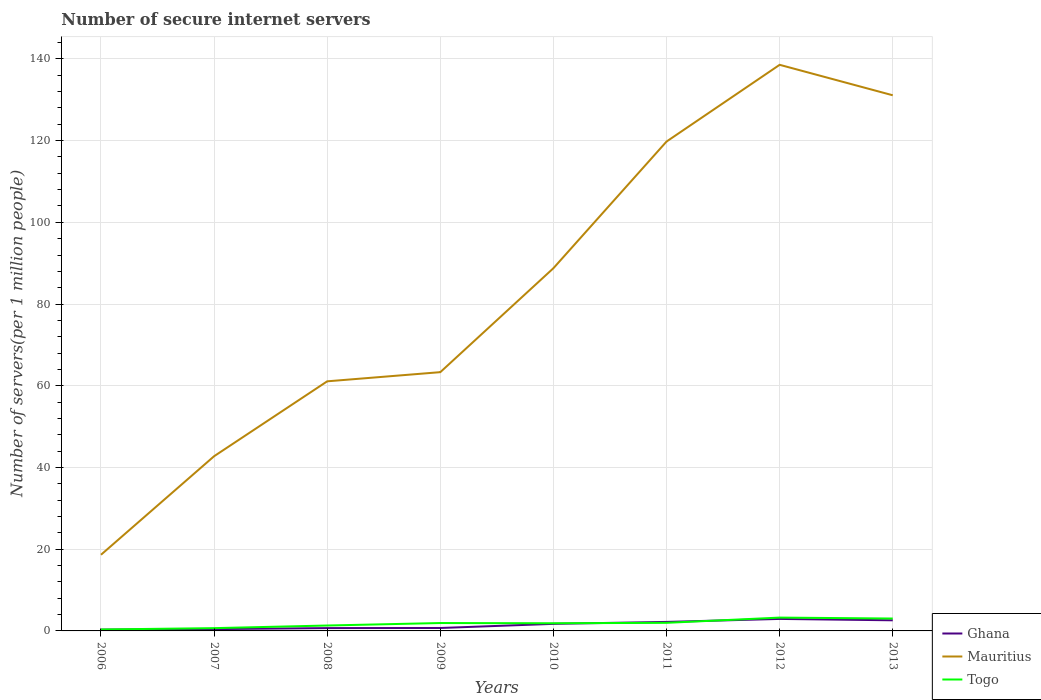Does the line corresponding to Togo intersect with the line corresponding to Mauritius?
Your answer should be very brief. No. Is the number of lines equal to the number of legend labels?
Offer a very short reply. Yes. Across all years, what is the maximum number of secure internet servers in Togo?
Make the answer very short. 0.35. In which year was the number of secure internet servers in Mauritius maximum?
Make the answer very short. 2006. What is the total number of secure internet servers in Mauritius in the graph?
Ensure brevity in your answer.  7.46. What is the difference between the highest and the second highest number of secure internet servers in Ghana?
Your answer should be compact. 2.62. What is the difference between the highest and the lowest number of secure internet servers in Ghana?
Make the answer very short. 4. How many years are there in the graph?
Provide a succinct answer. 8. Are the values on the major ticks of Y-axis written in scientific E-notation?
Ensure brevity in your answer.  No. Does the graph contain grids?
Offer a very short reply. Yes. Where does the legend appear in the graph?
Ensure brevity in your answer.  Bottom right. How many legend labels are there?
Offer a terse response. 3. What is the title of the graph?
Provide a short and direct response. Number of secure internet servers. What is the label or title of the X-axis?
Provide a succinct answer. Years. What is the label or title of the Y-axis?
Offer a very short reply. Number of servers(per 1 million people). What is the Number of servers(per 1 million people) in Ghana in 2006?
Keep it short and to the point. 0.32. What is the Number of servers(per 1 million people) of Mauritius in 2006?
Offer a very short reply. 18.64. What is the Number of servers(per 1 million people) in Togo in 2006?
Keep it short and to the point. 0.35. What is the Number of servers(per 1 million people) of Ghana in 2007?
Offer a very short reply. 0.44. What is the Number of servers(per 1 million people) in Mauritius in 2007?
Provide a succinct answer. 42.75. What is the Number of servers(per 1 million people) of Togo in 2007?
Your answer should be very brief. 0.68. What is the Number of servers(per 1 million people) in Ghana in 2008?
Provide a succinct answer. 0.69. What is the Number of servers(per 1 million people) in Mauritius in 2008?
Provide a short and direct response. 61.09. What is the Number of servers(per 1 million people) in Togo in 2008?
Ensure brevity in your answer.  1.32. What is the Number of servers(per 1 million people) in Ghana in 2009?
Ensure brevity in your answer.  0.72. What is the Number of servers(per 1 million people) of Mauritius in 2009?
Your answer should be very brief. 63.33. What is the Number of servers(per 1 million people) in Togo in 2009?
Your response must be concise. 1.93. What is the Number of servers(per 1 million people) of Ghana in 2010?
Offer a terse response. 1.73. What is the Number of servers(per 1 million people) in Mauritius in 2010?
Keep it short and to the point. 88.77. What is the Number of servers(per 1 million people) in Togo in 2010?
Keep it short and to the point. 1.88. What is the Number of servers(per 1 million people) in Ghana in 2011?
Give a very brief answer. 2.21. What is the Number of servers(per 1 million people) of Mauritius in 2011?
Offer a terse response. 119.77. What is the Number of servers(per 1 million people) in Togo in 2011?
Offer a terse response. 1.98. What is the Number of servers(per 1 million people) of Ghana in 2012?
Ensure brevity in your answer.  2.94. What is the Number of servers(per 1 million people) in Mauritius in 2012?
Give a very brief answer. 138.55. What is the Number of servers(per 1 million people) in Togo in 2012?
Offer a very short reply. 3.26. What is the Number of servers(per 1 million people) in Ghana in 2013?
Keep it short and to the point. 2.6. What is the Number of servers(per 1 million people) in Mauritius in 2013?
Your answer should be compact. 131.09. What is the Number of servers(per 1 million people) in Togo in 2013?
Your answer should be compact. 3.03. Across all years, what is the maximum Number of servers(per 1 million people) in Ghana?
Your response must be concise. 2.94. Across all years, what is the maximum Number of servers(per 1 million people) of Mauritius?
Offer a very short reply. 138.55. Across all years, what is the maximum Number of servers(per 1 million people) in Togo?
Give a very brief answer. 3.26. Across all years, what is the minimum Number of servers(per 1 million people) in Ghana?
Your response must be concise. 0.32. Across all years, what is the minimum Number of servers(per 1 million people) of Mauritius?
Offer a very short reply. 18.64. Across all years, what is the minimum Number of servers(per 1 million people) of Togo?
Offer a very short reply. 0.35. What is the total Number of servers(per 1 million people) in Ghana in the graph?
Give a very brief answer. 11.64. What is the total Number of servers(per 1 million people) in Mauritius in the graph?
Your answer should be very brief. 663.99. What is the total Number of servers(per 1 million people) of Togo in the graph?
Give a very brief answer. 14.43. What is the difference between the Number of servers(per 1 million people) in Ghana in 2006 and that in 2007?
Make the answer very short. -0.12. What is the difference between the Number of servers(per 1 million people) of Mauritius in 2006 and that in 2007?
Your answer should be very brief. -24.12. What is the difference between the Number of servers(per 1 million people) in Togo in 2006 and that in 2007?
Provide a short and direct response. -0.33. What is the difference between the Number of servers(per 1 million people) in Ghana in 2006 and that in 2008?
Provide a short and direct response. -0.37. What is the difference between the Number of servers(per 1 million people) of Mauritius in 2006 and that in 2008?
Offer a terse response. -42.45. What is the difference between the Number of servers(per 1 million people) of Togo in 2006 and that in 2008?
Make the answer very short. -0.97. What is the difference between the Number of servers(per 1 million people) in Ghana in 2006 and that in 2009?
Your answer should be very brief. -0.4. What is the difference between the Number of servers(per 1 million people) in Mauritius in 2006 and that in 2009?
Make the answer very short. -44.69. What is the difference between the Number of servers(per 1 million people) in Togo in 2006 and that in 2009?
Provide a succinct answer. -1.58. What is the difference between the Number of servers(per 1 million people) in Ghana in 2006 and that in 2010?
Give a very brief answer. -1.41. What is the difference between the Number of servers(per 1 million people) of Mauritius in 2006 and that in 2010?
Give a very brief answer. -70.13. What is the difference between the Number of servers(per 1 million people) in Togo in 2006 and that in 2010?
Your response must be concise. -1.53. What is the difference between the Number of servers(per 1 million people) in Ghana in 2006 and that in 2011?
Ensure brevity in your answer.  -1.89. What is the difference between the Number of servers(per 1 million people) in Mauritius in 2006 and that in 2011?
Keep it short and to the point. -101.13. What is the difference between the Number of servers(per 1 million people) in Togo in 2006 and that in 2011?
Offer a very short reply. -1.63. What is the difference between the Number of servers(per 1 million people) in Ghana in 2006 and that in 2012?
Make the answer very short. -2.62. What is the difference between the Number of servers(per 1 million people) in Mauritius in 2006 and that in 2012?
Keep it short and to the point. -119.91. What is the difference between the Number of servers(per 1 million people) in Togo in 2006 and that in 2012?
Keep it short and to the point. -2.91. What is the difference between the Number of servers(per 1 million people) of Ghana in 2006 and that in 2013?
Your response must be concise. -2.28. What is the difference between the Number of servers(per 1 million people) in Mauritius in 2006 and that in 2013?
Ensure brevity in your answer.  -112.45. What is the difference between the Number of servers(per 1 million people) of Togo in 2006 and that in 2013?
Provide a short and direct response. -2.68. What is the difference between the Number of servers(per 1 million people) of Ghana in 2007 and that in 2008?
Keep it short and to the point. -0.25. What is the difference between the Number of servers(per 1 million people) of Mauritius in 2007 and that in 2008?
Ensure brevity in your answer.  -18.33. What is the difference between the Number of servers(per 1 million people) of Togo in 2007 and that in 2008?
Your response must be concise. -0.64. What is the difference between the Number of servers(per 1 million people) of Ghana in 2007 and that in 2009?
Make the answer very short. -0.27. What is the difference between the Number of servers(per 1 million people) in Mauritius in 2007 and that in 2009?
Make the answer very short. -20.58. What is the difference between the Number of servers(per 1 million people) of Togo in 2007 and that in 2009?
Ensure brevity in your answer.  -1.25. What is the difference between the Number of servers(per 1 million people) in Ghana in 2007 and that in 2010?
Your response must be concise. -1.28. What is the difference between the Number of servers(per 1 million people) in Mauritius in 2007 and that in 2010?
Make the answer very short. -46.02. What is the difference between the Number of servers(per 1 million people) in Togo in 2007 and that in 2010?
Provide a succinct answer. -1.2. What is the difference between the Number of servers(per 1 million people) of Ghana in 2007 and that in 2011?
Your answer should be compact. -1.76. What is the difference between the Number of servers(per 1 million people) in Mauritius in 2007 and that in 2011?
Your answer should be very brief. -77.02. What is the difference between the Number of servers(per 1 million people) of Togo in 2007 and that in 2011?
Provide a succinct answer. -1.3. What is the difference between the Number of servers(per 1 million people) in Ghana in 2007 and that in 2012?
Give a very brief answer. -2.49. What is the difference between the Number of servers(per 1 million people) in Mauritius in 2007 and that in 2012?
Provide a short and direct response. -95.79. What is the difference between the Number of servers(per 1 million people) of Togo in 2007 and that in 2012?
Offer a very short reply. -2.58. What is the difference between the Number of servers(per 1 million people) in Ghana in 2007 and that in 2013?
Your response must be concise. -2.16. What is the difference between the Number of servers(per 1 million people) of Mauritius in 2007 and that in 2013?
Give a very brief answer. -88.34. What is the difference between the Number of servers(per 1 million people) in Togo in 2007 and that in 2013?
Give a very brief answer. -2.35. What is the difference between the Number of servers(per 1 million people) of Ghana in 2008 and that in 2009?
Keep it short and to the point. -0.02. What is the difference between the Number of servers(per 1 million people) in Mauritius in 2008 and that in 2009?
Provide a short and direct response. -2.24. What is the difference between the Number of servers(per 1 million people) in Togo in 2008 and that in 2009?
Your response must be concise. -0.61. What is the difference between the Number of servers(per 1 million people) in Ghana in 2008 and that in 2010?
Provide a short and direct response. -1.03. What is the difference between the Number of servers(per 1 million people) of Mauritius in 2008 and that in 2010?
Your answer should be compact. -27.68. What is the difference between the Number of servers(per 1 million people) in Togo in 2008 and that in 2010?
Offer a very short reply. -0.56. What is the difference between the Number of servers(per 1 million people) of Ghana in 2008 and that in 2011?
Offer a terse response. -1.51. What is the difference between the Number of servers(per 1 million people) in Mauritius in 2008 and that in 2011?
Your answer should be compact. -58.68. What is the difference between the Number of servers(per 1 million people) in Togo in 2008 and that in 2011?
Offer a very short reply. -0.66. What is the difference between the Number of servers(per 1 million people) of Ghana in 2008 and that in 2012?
Offer a terse response. -2.24. What is the difference between the Number of servers(per 1 million people) in Mauritius in 2008 and that in 2012?
Keep it short and to the point. -77.46. What is the difference between the Number of servers(per 1 million people) in Togo in 2008 and that in 2012?
Provide a short and direct response. -1.94. What is the difference between the Number of servers(per 1 million people) in Ghana in 2008 and that in 2013?
Make the answer very short. -1.91. What is the difference between the Number of servers(per 1 million people) of Mauritius in 2008 and that in 2013?
Make the answer very short. -70.01. What is the difference between the Number of servers(per 1 million people) in Togo in 2008 and that in 2013?
Provide a short and direct response. -1.71. What is the difference between the Number of servers(per 1 million people) of Ghana in 2009 and that in 2010?
Provide a succinct answer. -1.01. What is the difference between the Number of servers(per 1 million people) in Mauritius in 2009 and that in 2010?
Keep it short and to the point. -25.44. What is the difference between the Number of servers(per 1 million people) of Togo in 2009 and that in 2010?
Keep it short and to the point. 0.05. What is the difference between the Number of servers(per 1 million people) of Ghana in 2009 and that in 2011?
Give a very brief answer. -1.49. What is the difference between the Number of servers(per 1 million people) of Mauritius in 2009 and that in 2011?
Make the answer very short. -56.44. What is the difference between the Number of servers(per 1 million people) of Togo in 2009 and that in 2011?
Your response must be concise. -0.05. What is the difference between the Number of servers(per 1 million people) in Ghana in 2009 and that in 2012?
Ensure brevity in your answer.  -2.22. What is the difference between the Number of servers(per 1 million people) of Mauritius in 2009 and that in 2012?
Give a very brief answer. -75.22. What is the difference between the Number of servers(per 1 million people) in Togo in 2009 and that in 2012?
Ensure brevity in your answer.  -1.33. What is the difference between the Number of servers(per 1 million people) of Ghana in 2009 and that in 2013?
Give a very brief answer. -1.88. What is the difference between the Number of servers(per 1 million people) of Mauritius in 2009 and that in 2013?
Give a very brief answer. -67.76. What is the difference between the Number of servers(per 1 million people) in Togo in 2009 and that in 2013?
Make the answer very short. -1.1. What is the difference between the Number of servers(per 1 million people) in Ghana in 2010 and that in 2011?
Offer a terse response. -0.48. What is the difference between the Number of servers(per 1 million people) in Mauritius in 2010 and that in 2011?
Give a very brief answer. -31. What is the difference between the Number of servers(per 1 million people) in Togo in 2010 and that in 2011?
Offer a terse response. -0.1. What is the difference between the Number of servers(per 1 million people) of Ghana in 2010 and that in 2012?
Provide a succinct answer. -1.21. What is the difference between the Number of servers(per 1 million people) of Mauritius in 2010 and that in 2012?
Keep it short and to the point. -49.78. What is the difference between the Number of servers(per 1 million people) in Togo in 2010 and that in 2012?
Keep it short and to the point. -1.38. What is the difference between the Number of servers(per 1 million people) in Ghana in 2010 and that in 2013?
Provide a succinct answer. -0.87. What is the difference between the Number of servers(per 1 million people) in Mauritius in 2010 and that in 2013?
Offer a terse response. -42.32. What is the difference between the Number of servers(per 1 million people) of Togo in 2010 and that in 2013?
Make the answer very short. -1.15. What is the difference between the Number of servers(per 1 million people) of Ghana in 2011 and that in 2012?
Give a very brief answer. -0.73. What is the difference between the Number of servers(per 1 million people) in Mauritius in 2011 and that in 2012?
Your response must be concise. -18.78. What is the difference between the Number of servers(per 1 million people) in Togo in 2011 and that in 2012?
Provide a short and direct response. -1.28. What is the difference between the Number of servers(per 1 million people) in Ghana in 2011 and that in 2013?
Offer a terse response. -0.39. What is the difference between the Number of servers(per 1 million people) in Mauritius in 2011 and that in 2013?
Keep it short and to the point. -11.32. What is the difference between the Number of servers(per 1 million people) of Togo in 2011 and that in 2013?
Your response must be concise. -1.05. What is the difference between the Number of servers(per 1 million people) of Ghana in 2012 and that in 2013?
Make the answer very short. 0.34. What is the difference between the Number of servers(per 1 million people) in Mauritius in 2012 and that in 2013?
Your answer should be very brief. 7.46. What is the difference between the Number of servers(per 1 million people) in Togo in 2012 and that in 2013?
Keep it short and to the point. 0.23. What is the difference between the Number of servers(per 1 million people) in Ghana in 2006 and the Number of servers(per 1 million people) in Mauritius in 2007?
Offer a very short reply. -42.44. What is the difference between the Number of servers(per 1 million people) of Ghana in 2006 and the Number of servers(per 1 million people) of Togo in 2007?
Keep it short and to the point. -0.36. What is the difference between the Number of servers(per 1 million people) in Mauritius in 2006 and the Number of servers(per 1 million people) in Togo in 2007?
Offer a terse response. 17.96. What is the difference between the Number of servers(per 1 million people) in Ghana in 2006 and the Number of servers(per 1 million people) in Mauritius in 2008?
Your answer should be very brief. -60.77. What is the difference between the Number of servers(per 1 million people) in Ghana in 2006 and the Number of servers(per 1 million people) in Togo in 2008?
Give a very brief answer. -1. What is the difference between the Number of servers(per 1 million people) of Mauritius in 2006 and the Number of servers(per 1 million people) of Togo in 2008?
Provide a short and direct response. 17.32. What is the difference between the Number of servers(per 1 million people) in Ghana in 2006 and the Number of servers(per 1 million people) in Mauritius in 2009?
Offer a terse response. -63.01. What is the difference between the Number of servers(per 1 million people) in Ghana in 2006 and the Number of servers(per 1 million people) in Togo in 2009?
Offer a terse response. -1.61. What is the difference between the Number of servers(per 1 million people) of Mauritius in 2006 and the Number of servers(per 1 million people) of Togo in 2009?
Offer a terse response. 16.71. What is the difference between the Number of servers(per 1 million people) in Ghana in 2006 and the Number of servers(per 1 million people) in Mauritius in 2010?
Provide a succinct answer. -88.45. What is the difference between the Number of servers(per 1 million people) of Ghana in 2006 and the Number of servers(per 1 million people) of Togo in 2010?
Ensure brevity in your answer.  -1.56. What is the difference between the Number of servers(per 1 million people) in Mauritius in 2006 and the Number of servers(per 1 million people) in Togo in 2010?
Your answer should be compact. 16.76. What is the difference between the Number of servers(per 1 million people) of Ghana in 2006 and the Number of servers(per 1 million people) of Mauritius in 2011?
Your answer should be compact. -119.45. What is the difference between the Number of servers(per 1 million people) of Ghana in 2006 and the Number of servers(per 1 million people) of Togo in 2011?
Offer a terse response. -1.66. What is the difference between the Number of servers(per 1 million people) of Mauritius in 2006 and the Number of servers(per 1 million people) of Togo in 2011?
Your answer should be very brief. 16.66. What is the difference between the Number of servers(per 1 million people) in Ghana in 2006 and the Number of servers(per 1 million people) in Mauritius in 2012?
Provide a succinct answer. -138.23. What is the difference between the Number of servers(per 1 million people) of Ghana in 2006 and the Number of servers(per 1 million people) of Togo in 2012?
Provide a short and direct response. -2.94. What is the difference between the Number of servers(per 1 million people) of Mauritius in 2006 and the Number of servers(per 1 million people) of Togo in 2012?
Provide a succinct answer. 15.38. What is the difference between the Number of servers(per 1 million people) in Ghana in 2006 and the Number of servers(per 1 million people) in Mauritius in 2013?
Your response must be concise. -130.77. What is the difference between the Number of servers(per 1 million people) in Ghana in 2006 and the Number of servers(per 1 million people) in Togo in 2013?
Your response must be concise. -2.71. What is the difference between the Number of servers(per 1 million people) of Mauritius in 2006 and the Number of servers(per 1 million people) of Togo in 2013?
Offer a very short reply. 15.61. What is the difference between the Number of servers(per 1 million people) of Ghana in 2007 and the Number of servers(per 1 million people) of Mauritius in 2008?
Offer a very short reply. -60.64. What is the difference between the Number of servers(per 1 million people) in Ghana in 2007 and the Number of servers(per 1 million people) in Togo in 2008?
Keep it short and to the point. -0.88. What is the difference between the Number of servers(per 1 million people) in Mauritius in 2007 and the Number of servers(per 1 million people) in Togo in 2008?
Provide a succinct answer. 41.43. What is the difference between the Number of servers(per 1 million people) in Ghana in 2007 and the Number of servers(per 1 million people) in Mauritius in 2009?
Make the answer very short. -62.89. What is the difference between the Number of servers(per 1 million people) of Ghana in 2007 and the Number of servers(per 1 million people) of Togo in 2009?
Provide a short and direct response. -1.49. What is the difference between the Number of servers(per 1 million people) in Mauritius in 2007 and the Number of servers(per 1 million people) in Togo in 2009?
Offer a very short reply. 40.83. What is the difference between the Number of servers(per 1 million people) of Ghana in 2007 and the Number of servers(per 1 million people) of Mauritius in 2010?
Your answer should be very brief. -88.33. What is the difference between the Number of servers(per 1 million people) of Ghana in 2007 and the Number of servers(per 1 million people) of Togo in 2010?
Ensure brevity in your answer.  -1.43. What is the difference between the Number of servers(per 1 million people) in Mauritius in 2007 and the Number of servers(per 1 million people) in Togo in 2010?
Your answer should be compact. 40.88. What is the difference between the Number of servers(per 1 million people) in Ghana in 2007 and the Number of servers(per 1 million people) in Mauritius in 2011?
Your response must be concise. -119.33. What is the difference between the Number of servers(per 1 million people) of Ghana in 2007 and the Number of servers(per 1 million people) of Togo in 2011?
Offer a very short reply. -1.54. What is the difference between the Number of servers(per 1 million people) of Mauritius in 2007 and the Number of servers(per 1 million people) of Togo in 2011?
Keep it short and to the point. 40.77. What is the difference between the Number of servers(per 1 million people) of Ghana in 2007 and the Number of servers(per 1 million people) of Mauritius in 2012?
Provide a short and direct response. -138.1. What is the difference between the Number of servers(per 1 million people) of Ghana in 2007 and the Number of servers(per 1 million people) of Togo in 2012?
Provide a succinct answer. -2.82. What is the difference between the Number of servers(per 1 million people) in Mauritius in 2007 and the Number of servers(per 1 million people) in Togo in 2012?
Offer a terse response. 39.49. What is the difference between the Number of servers(per 1 million people) of Ghana in 2007 and the Number of servers(per 1 million people) of Mauritius in 2013?
Make the answer very short. -130.65. What is the difference between the Number of servers(per 1 million people) in Ghana in 2007 and the Number of servers(per 1 million people) in Togo in 2013?
Give a very brief answer. -2.59. What is the difference between the Number of servers(per 1 million people) in Mauritius in 2007 and the Number of servers(per 1 million people) in Togo in 2013?
Keep it short and to the point. 39.72. What is the difference between the Number of servers(per 1 million people) in Ghana in 2008 and the Number of servers(per 1 million people) in Mauritius in 2009?
Keep it short and to the point. -62.64. What is the difference between the Number of servers(per 1 million people) in Ghana in 2008 and the Number of servers(per 1 million people) in Togo in 2009?
Make the answer very short. -1.24. What is the difference between the Number of servers(per 1 million people) in Mauritius in 2008 and the Number of servers(per 1 million people) in Togo in 2009?
Ensure brevity in your answer.  59.16. What is the difference between the Number of servers(per 1 million people) of Ghana in 2008 and the Number of servers(per 1 million people) of Mauritius in 2010?
Offer a very short reply. -88.08. What is the difference between the Number of servers(per 1 million people) of Ghana in 2008 and the Number of servers(per 1 million people) of Togo in 2010?
Make the answer very short. -1.19. What is the difference between the Number of servers(per 1 million people) of Mauritius in 2008 and the Number of servers(per 1 million people) of Togo in 2010?
Provide a short and direct response. 59.21. What is the difference between the Number of servers(per 1 million people) in Ghana in 2008 and the Number of servers(per 1 million people) in Mauritius in 2011?
Keep it short and to the point. -119.08. What is the difference between the Number of servers(per 1 million people) of Ghana in 2008 and the Number of servers(per 1 million people) of Togo in 2011?
Provide a succinct answer. -1.29. What is the difference between the Number of servers(per 1 million people) of Mauritius in 2008 and the Number of servers(per 1 million people) of Togo in 2011?
Provide a short and direct response. 59.11. What is the difference between the Number of servers(per 1 million people) in Ghana in 2008 and the Number of servers(per 1 million people) in Mauritius in 2012?
Offer a very short reply. -137.86. What is the difference between the Number of servers(per 1 million people) of Ghana in 2008 and the Number of servers(per 1 million people) of Togo in 2012?
Keep it short and to the point. -2.57. What is the difference between the Number of servers(per 1 million people) of Mauritius in 2008 and the Number of servers(per 1 million people) of Togo in 2012?
Offer a terse response. 57.83. What is the difference between the Number of servers(per 1 million people) in Ghana in 2008 and the Number of servers(per 1 million people) in Mauritius in 2013?
Make the answer very short. -130.4. What is the difference between the Number of servers(per 1 million people) in Ghana in 2008 and the Number of servers(per 1 million people) in Togo in 2013?
Provide a succinct answer. -2.34. What is the difference between the Number of servers(per 1 million people) in Mauritius in 2008 and the Number of servers(per 1 million people) in Togo in 2013?
Your response must be concise. 58.06. What is the difference between the Number of servers(per 1 million people) in Ghana in 2009 and the Number of servers(per 1 million people) in Mauritius in 2010?
Offer a very short reply. -88.05. What is the difference between the Number of servers(per 1 million people) in Ghana in 2009 and the Number of servers(per 1 million people) in Togo in 2010?
Your response must be concise. -1.16. What is the difference between the Number of servers(per 1 million people) of Mauritius in 2009 and the Number of servers(per 1 million people) of Togo in 2010?
Offer a terse response. 61.45. What is the difference between the Number of servers(per 1 million people) of Ghana in 2009 and the Number of servers(per 1 million people) of Mauritius in 2011?
Offer a very short reply. -119.05. What is the difference between the Number of servers(per 1 million people) in Ghana in 2009 and the Number of servers(per 1 million people) in Togo in 2011?
Your response must be concise. -1.26. What is the difference between the Number of servers(per 1 million people) in Mauritius in 2009 and the Number of servers(per 1 million people) in Togo in 2011?
Your answer should be very brief. 61.35. What is the difference between the Number of servers(per 1 million people) in Ghana in 2009 and the Number of servers(per 1 million people) in Mauritius in 2012?
Make the answer very short. -137.83. What is the difference between the Number of servers(per 1 million people) in Ghana in 2009 and the Number of servers(per 1 million people) in Togo in 2012?
Keep it short and to the point. -2.54. What is the difference between the Number of servers(per 1 million people) in Mauritius in 2009 and the Number of servers(per 1 million people) in Togo in 2012?
Provide a short and direct response. 60.07. What is the difference between the Number of servers(per 1 million people) in Ghana in 2009 and the Number of servers(per 1 million people) in Mauritius in 2013?
Offer a terse response. -130.38. What is the difference between the Number of servers(per 1 million people) in Ghana in 2009 and the Number of servers(per 1 million people) in Togo in 2013?
Offer a terse response. -2.31. What is the difference between the Number of servers(per 1 million people) of Mauritius in 2009 and the Number of servers(per 1 million people) of Togo in 2013?
Your answer should be very brief. 60.3. What is the difference between the Number of servers(per 1 million people) of Ghana in 2010 and the Number of servers(per 1 million people) of Mauritius in 2011?
Give a very brief answer. -118.04. What is the difference between the Number of servers(per 1 million people) of Ghana in 2010 and the Number of servers(per 1 million people) of Togo in 2011?
Your response must be concise. -0.25. What is the difference between the Number of servers(per 1 million people) in Mauritius in 2010 and the Number of servers(per 1 million people) in Togo in 2011?
Offer a very short reply. 86.79. What is the difference between the Number of servers(per 1 million people) in Ghana in 2010 and the Number of servers(per 1 million people) in Mauritius in 2012?
Ensure brevity in your answer.  -136.82. What is the difference between the Number of servers(per 1 million people) of Ghana in 2010 and the Number of servers(per 1 million people) of Togo in 2012?
Offer a very short reply. -1.53. What is the difference between the Number of servers(per 1 million people) of Mauritius in 2010 and the Number of servers(per 1 million people) of Togo in 2012?
Ensure brevity in your answer.  85.51. What is the difference between the Number of servers(per 1 million people) in Ghana in 2010 and the Number of servers(per 1 million people) in Mauritius in 2013?
Provide a succinct answer. -129.37. What is the difference between the Number of servers(per 1 million people) in Ghana in 2010 and the Number of servers(per 1 million people) in Togo in 2013?
Your response must be concise. -1.3. What is the difference between the Number of servers(per 1 million people) in Mauritius in 2010 and the Number of servers(per 1 million people) in Togo in 2013?
Your answer should be compact. 85.74. What is the difference between the Number of servers(per 1 million people) in Ghana in 2011 and the Number of servers(per 1 million people) in Mauritius in 2012?
Give a very brief answer. -136.34. What is the difference between the Number of servers(per 1 million people) in Ghana in 2011 and the Number of servers(per 1 million people) in Togo in 2012?
Offer a terse response. -1.06. What is the difference between the Number of servers(per 1 million people) in Mauritius in 2011 and the Number of servers(per 1 million people) in Togo in 2012?
Offer a terse response. 116.51. What is the difference between the Number of servers(per 1 million people) in Ghana in 2011 and the Number of servers(per 1 million people) in Mauritius in 2013?
Offer a very short reply. -128.89. What is the difference between the Number of servers(per 1 million people) in Ghana in 2011 and the Number of servers(per 1 million people) in Togo in 2013?
Provide a short and direct response. -0.82. What is the difference between the Number of servers(per 1 million people) of Mauritius in 2011 and the Number of servers(per 1 million people) of Togo in 2013?
Make the answer very short. 116.74. What is the difference between the Number of servers(per 1 million people) of Ghana in 2012 and the Number of servers(per 1 million people) of Mauritius in 2013?
Offer a very short reply. -128.16. What is the difference between the Number of servers(per 1 million people) in Ghana in 2012 and the Number of servers(per 1 million people) in Togo in 2013?
Your answer should be compact. -0.09. What is the difference between the Number of servers(per 1 million people) of Mauritius in 2012 and the Number of servers(per 1 million people) of Togo in 2013?
Your response must be concise. 135.52. What is the average Number of servers(per 1 million people) of Ghana per year?
Provide a short and direct response. 1.46. What is the average Number of servers(per 1 million people) in Mauritius per year?
Give a very brief answer. 83. What is the average Number of servers(per 1 million people) in Togo per year?
Give a very brief answer. 1.8. In the year 2006, what is the difference between the Number of servers(per 1 million people) in Ghana and Number of servers(per 1 million people) in Mauritius?
Provide a short and direct response. -18.32. In the year 2006, what is the difference between the Number of servers(per 1 million people) in Ghana and Number of servers(per 1 million people) in Togo?
Your answer should be compact. -0.03. In the year 2006, what is the difference between the Number of servers(per 1 million people) in Mauritius and Number of servers(per 1 million people) in Togo?
Your answer should be very brief. 18.29. In the year 2007, what is the difference between the Number of servers(per 1 million people) of Ghana and Number of servers(per 1 million people) of Mauritius?
Your answer should be compact. -42.31. In the year 2007, what is the difference between the Number of servers(per 1 million people) of Ghana and Number of servers(per 1 million people) of Togo?
Your answer should be compact. -0.24. In the year 2007, what is the difference between the Number of servers(per 1 million people) of Mauritius and Number of servers(per 1 million people) of Togo?
Provide a short and direct response. 42.08. In the year 2008, what is the difference between the Number of servers(per 1 million people) of Ghana and Number of servers(per 1 million people) of Mauritius?
Offer a terse response. -60.4. In the year 2008, what is the difference between the Number of servers(per 1 million people) of Ghana and Number of servers(per 1 million people) of Togo?
Ensure brevity in your answer.  -0.63. In the year 2008, what is the difference between the Number of servers(per 1 million people) in Mauritius and Number of servers(per 1 million people) in Togo?
Make the answer very short. 59.77. In the year 2009, what is the difference between the Number of servers(per 1 million people) in Ghana and Number of servers(per 1 million people) in Mauritius?
Offer a terse response. -62.61. In the year 2009, what is the difference between the Number of servers(per 1 million people) in Ghana and Number of servers(per 1 million people) in Togo?
Your answer should be compact. -1.21. In the year 2009, what is the difference between the Number of servers(per 1 million people) in Mauritius and Number of servers(per 1 million people) in Togo?
Provide a short and direct response. 61.4. In the year 2010, what is the difference between the Number of servers(per 1 million people) of Ghana and Number of servers(per 1 million people) of Mauritius?
Offer a terse response. -87.04. In the year 2010, what is the difference between the Number of servers(per 1 million people) of Ghana and Number of servers(per 1 million people) of Togo?
Offer a very short reply. -0.15. In the year 2010, what is the difference between the Number of servers(per 1 million people) in Mauritius and Number of servers(per 1 million people) in Togo?
Provide a short and direct response. 86.89. In the year 2011, what is the difference between the Number of servers(per 1 million people) of Ghana and Number of servers(per 1 million people) of Mauritius?
Provide a succinct answer. -117.56. In the year 2011, what is the difference between the Number of servers(per 1 million people) of Ghana and Number of servers(per 1 million people) of Togo?
Make the answer very short. 0.23. In the year 2011, what is the difference between the Number of servers(per 1 million people) of Mauritius and Number of servers(per 1 million people) of Togo?
Ensure brevity in your answer.  117.79. In the year 2012, what is the difference between the Number of servers(per 1 million people) of Ghana and Number of servers(per 1 million people) of Mauritius?
Make the answer very short. -135.61. In the year 2012, what is the difference between the Number of servers(per 1 million people) of Ghana and Number of servers(per 1 million people) of Togo?
Your response must be concise. -0.33. In the year 2012, what is the difference between the Number of servers(per 1 million people) in Mauritius and Number of servers(per 1 million people) in Togo?
Your response must be concise. 135.29. In the year 2013, what is the difference between the Number of servers(per 1 million people) in Ghana and Number of servers(per 1 million people) in Mauritius?
Offer a terse response. -128.49. In the year 2013, what is the difference between the Number of servers(per 1 million people) of Ghana and Number of servers(per 1 million people) of Togo?
Offer a terse response. -0.43. In the year 2013, what is the difference between the Number of servers(per 1 million people) of Mauritius and Number of servers(per 1 million people) of Togo?
Offer a terse response. 128.06. What is the ratio of the Number of servers(per 1 million people) in Ghana in 2006 to that in 2007?
Provide a short and direct response. 0.72. What is the ratio of the Number of servers(per 1 million people) of Mauritius in 2006 to that in 2007?
Provide a short and direct response. 0.44. What is the ratio of the Number of servers(per 1 million people) in Togo in 2006 to that in 2007?
Make the answer very short. 0.51. What is the ratio of the Number of servers(per 1 million people) in Ghana in 2006 to that in 2008?
Your answer should be very brief. 0.46. What is the ratio of the Number of servers(per 1 million people) in Mauritius in 2006 to that in 2008?
Offer a terse response. 0.31. What is the ratio of the Number of servers(per 1 million people) in Togo in 2006 to that in 2008?
Your response must be concise. 0.26. What is the ratio of the Number of servers(per 1 million people) of Ghana in 2006 to that in 2009?
Provide a short and direct response. 0.44. What is the ratio of the Number of servers(per 1 million people) in Mauritius in 2006 to that in 2009?
Give a very brief answer. 0.29. What is the ratio of the Number of servers(per 1 million people) of Togo in 2006 to that in 2009?
Offer a very short reply. 0.18. What is the ratio of the Number of servers(per 1 million people) of Ghana in 2006 to that in 2010?
Your response must be concise. 0.18. What is the ratio of the Number of servers(per 1 million people) of Mauritius in 2006 to that in 2010?
Offer a terse response. 0.21. What is the ratio of the Number of servers(per 1 million people) in Togo in 2006 to that in 2010?
Provide a short and direct response. 0.19. What is the ratio of the Number of servers(per 1 million people) in Ghana in 2006 to that in 2011?
Ensure brevity in your answer.  0.14. What is the ratio of the Number of servers(per 1 million people) of Mauritius in 2006 to that in 2011?
Provide a short and direct response. 0.16. What is the ratio of the Number of servers(per 1 million people) of Togo in 2006 to that in 2011?
Your answer should be very brief. 0.18. What is the ratio of the Number of servers(per 1 million people) of Ghana in 2006 to that in 2012?
Your answer should be compact. 0.11. What is the ratio of the Number of servers(per 1 million people) of Mauritius in 2006 to that in 2012?
Offer a terse response. 0.13. What is the ratio of the Number of servers(per 1 million people) in Togo in 2006 to that in 2012?
Provide a short and direct response. 0.11. What is the ratio of the Number of servers(per 1 million people) of Ghana in 2006 to that in 2013?
Ensure brevity in your answer.  0.12. What is the ratio of the Number of servers(per 1 million people) of Mauritius in 2006 to that in 2013?
Give a very brief answer. 0.14. What is the ratio of the Number of servers(per 1 million people) of Togo in 2006 to that in 2013?
Provide a short and direct response. 0.12. What is the ratio of the Number of servers(per 1 million people) in Ghana in 2007 to that in 2008?
Keep it short and to the point. 0.64. What is the ratio of the Number of servers(per 1 million people) of Mauritius in 2007 to that in 2008?
Your answer should be compact. 0.7. What is the ratio of the Number of servers(per 1 million people) of Togo in 2007 to that in 2008?
Keep it short and to the point. 0.51. What is the ratio of the Number of servers(per 1 million people) of Ghana in 2007 to that in 2009?
Offer a terse response. 0.62. What is the ratio of the Number of servers(per 1 million people) of Mauritius in 2007 to that in 2009?
Ensure brevity in your answer.  0.68. What is the ratio of the Number of servers(per 1 million people) of Togo in 2007 to that in 2009?
Your answer should be compact. 0.35. What is the ratio of the Number of servers(per 1 million people) of Ghana in 2007 to that in 2010?
Provide a succinct answer. 0.26. What is the ratio of the Number of servers(per 1 million people) of Mauritius in 2007 to that in 2010?
Your answer should be compact. 0.48. What is the ratio of the Number of servers(per 1 million people) of Togo in 2007 to that in 2010?
Keep it short and to the point. 0.36. What is the ratio of the Number of servers(per 1 million people) of Ghana in 2007 to that in 2011?
Provide a short and direct response. 0.2. What is the ratio of the Number of servers(per 1 million people) in Mauritius in 2007 to that in 2011?
Provide a short and direct response. 0.36. What is the ratio of the Number of servers(per 1 million people) in Togo in 2007 to that in 2011?
Your answer should be compact. 0.34. What is the ratio of the Number of servers(per 1 million people) of Ghana in 2007 to that in 2012?
Your answer should be compact. 0.15. What is the ratio of the Number of servers(per 1 million people) in Mauritius in 2007 to that in 2012?
Keep it short and to the point. 0.31. What is the ratio of the Number of servers(per 1 million people) in Togo in 2007 to that in 2012?
Keep it short and to the point. 0.21. What is the ratio of the Number of servers(per 1 million people) in Ghana in 2007 to that in 2013?
Give a very brief answer. 0.17. What is the ratio of the Number of servers(per 1 million people) in Mauritius in 2007 to that in 2013?
Your answer should be compact. 0.33. What is the ratio of the Number of servers(per 1 million people) in Togo in 2007 to that in 2013?
Provide a succinct answer. 0.22. What is the ratio of the Number of servers(per 1 million people) of Ghana in 2008 to that in 2009?
Provide a short and direct response. 0.97. What is the ratio of the Number of servers(per 1 million people) in Mauritius in 2008 to that in 2009?
Provide a succinct answer. 0.96. What is the ratio of the Number of servers(per 1 million people) of Togo in 2008 to that in 2009?
Provide a short and direct response. 0.69. What is the ratio of the Number of servers(per 1 million people) of Ghana in 2008 to that in 2010?
Give a very brief answer. 0.4. What is the ratio of the Number of servers(per 1 million people) in Mauritius in 2008 to that in 2010?
Your answer should be very brief. 0.69. What is the ratio of the Number of servers(per 1 million people) in Togo in 2008 to that in 2010?
Keep it short and to the point. 0.7. What is the ratio of the Number of servers(per 1 million people) in Ghana in 2008 to that in 2011?
Ensure brevity in your answer.  0.31. What is the ratio of the Number of servers(per 1 million people) of Mauritius in 2008 to that in 2011?
Provide a short and direct response. 0.51. What is the ratio of the Number of servers(per 1 million people) of Togo in 2008 to that in 2011?
Provide a succinct answer. 0.67. What is the ratio of the Number of servers(per 1 million people) in Ghana in 2008 to that in 2012?
Ensure brevity in your answer.  0.24. What is the ratio of the Number of servers(per 1 million people) in Mauritius in 2008 to that in 2012?
Your response must be concise. 0.44. What is the ratio of the Number of servers(per 1 million people) of Togo in 2008 to that in 2012?
Offer a terse response. 0.41. What is the ratio of the Number of servers(per 1 million people) in Ghana in 2008 to that in 2013?
Give a very brief answer. 0.27. What is the ratio of the Number of servers(per 1 million people) of Mauritius in 2008 to that in 2013?
Your response must be concise. 0.47. What is the ratio of the Number of servers(per 1 million people) of Togo in 2008 to that in 2013?
Offer a terse response. 0.44. What is the ratio of the Number of servers(per 1 million people) in Ghana in 2009 to that in 2010?
Your answer should be compact. 0.42. What is the ratio of the Number of servers(per 1 million people) of Mauritius in 2009 to that in 2010?
Offer a terse response. 0.71. What is the ratio of the Number of servers(per 1 million people) in Togo in 2009 to that in 2010?
Provide a short and direct response. 1.03. What is the ratio of the Number of servers(per 1 million people) of Ghana in 2009 to that in 2011?
Give a very brief answer. 0.32. What is the ratio of the Number of servers(per 1 million people) of Mauritius in 2009 to that in 2011?
Offer a terse response. 0.53. What is the ratio of the Number of servers(per 1 million people) of Togo in 2009 to that in 2011?
Your response must be concise. 0.97. What is the ratio of the Number of servers(per 1 million people) in Ghana in 2009 to that in 2012?
Give a very brief answer. 0.24. What is the ratio of the Number of servers(per 1 million people) in Mauritius in 2009 to that in 2012?
Your response must be concise. 0.46. What is the ratio of the Number of servers(per 1 million people) of Togo in 2009 to that in 2012?
Offer a terse response. 0.59. What is the ratio of the Number of servers(per 1 million people) in Ghana in 2009 to that in 2013?
Your answer should be compact. 0.28. What is the ratio of the Number of servers(per 1 million people) in Mauritius in 2009 to that in 2013?
Provide a short and direct response. 0.48. What is the ratio of the Number of servers(per 1 million people) in Togo in 2009 to that in 2013?
Your response must be concise. 0.64. What is the ratio of the Number of servers(per 1 million people) of Ghana in 2010 to that in 2011?
Your answer should be very brief. 0.78. What is the ratio of the Number of servers(per 1 million people) of Mauritius in 2010 to that in 2011?
Make the answer very short. 0.74. What is the ratio of the Number of servers(per 1 million people) of Togo in 2010 to that in 2011?
Your answer should be very brief. 0.95. What is the ratio of the Number of servers(per 1 million people) of Ghana in 2010 to that in 2012?
Make the answer very short. 0.59. What is the ratio of the Number of servers(per 1 million people) in Mauritius in 2010 to that in 2012?
Provide a succinct answer. 0.64. What is the ratio of the Number of servers(per 1 million people) of Togo in 2010 to that in 2012?
Ensure brevity in your answer.  0.58. What is the ratio of the Number of servers(per 1 million people) in Ghana in 2010 to that in 2013?
Keep it short and to the point. 0.66. What is the ratio of the Number of servers(per 1 million people) in Mauritius in 2010 to that in 2013?
Keep it short and to the point. 0.68. What is the ratio of the Number of servers(per 1 million people) of Togo in 2010 to that in 2013?
Give a very brief answer. 0.62. What is the ratio of the Number of servers(per 1 million people) in Ghana in 2011 to that in 2012?
Keep it short and to the point. 0.75. What is the ratio of the Number of servers(per 1 million people) of Mauritius in 2011 to that in 2012?
Keep it short and to the point. 0.86. What is the ratio of the Number of servers(per 1 million people) of Togo in 2011 to that in 2012?
Offer a terse response. 0.61. What is the ratio of the Number of servers(per 1 million people) of Ghana in 2011 to that in 2013?
Offer a very short reply. 0.85. What is the ratio of the Number of servers(per 1 million people) of Mauritius in 2011 to that in 2013?
Your answer should be compact. 0.91. What is the ratio of the Number of servers(per 1 million people) in Togo in 2011 to that in 2013?
Offer a very short reply. 0.65. What is the ratio of the Number of servers(per 1 million people) of Ghana in 2012 to that in 2013?
Give a very brief answer. 1.13. What is the ratio of the Number of servers(per 1 million people) in Mauritius in 2012 to that in 2013?
Your answer should be very brief. 1.06. What is the ratio of the Number of servers(per 1 million people) of Togo in 2012 to that in 2013?
Your answer should be very brief. 1.08. What is the difference between the highest and the second highest Number of servers(per 1 million people) of Ghana?
Ensure brevity in your answer.  0.34. What is the difference between the highest and the second highest Number of servers(per 1 million people) in Mauritius?
Keep it short and to the point. 7.46. What is the difference between the highest and the second highest Number of servers(per 1 million people) in Togo?
Provide a short and direct response. 0.23. What is the difference between the highest and the lowest Number of servers(per 1 million people) of Ghana?
Make the answer very short. 2.62. What is the difference between the highest and the lowest Number of servers(per 1 million people) of Mauritius?
Your response must be concise. 119.91. What is the difference between the highest and the lowest Number of servers(per 1 million people) of Togo?
Give a very brief answer. 2.91. 